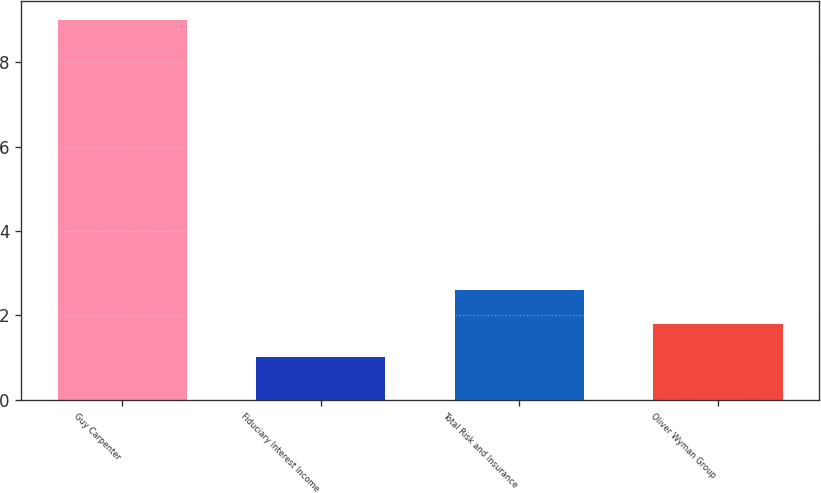Convert chart to OTSL. <chart><loc_0><loc_0><loc_500><loc_500><bar_chart><fcel>Guy Carpenter<fcel>Fiduciary Interest Income<fcel>Total Risk and Insurance<fcel>Oliver Wyman Group<nl><fcel>9<fcel>1<fcel>2.6<fcel>1.8<nl></chart> 